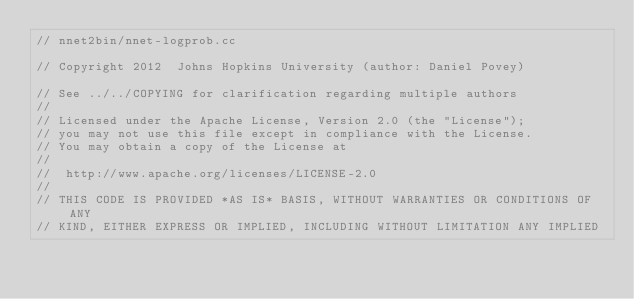Convert code to text. <code><loc_0><loc_0><loc_500><loc_500><_C++_>// nnet2bin/nnet-logprob.cc

// Copyright 2012  Johns Hopkins University (author: Daniel Povey)

// See ../../COPYING for clarification regarding multiple authors
//
// Licensed under the Apache License, Version 2.0 (the "License");
// you may not use this file except in compliance with the License.
// You may obtain a copy of the License at
//
//  http://www.apache.org/licenses/LICENSE-2.0
//
// THIS CODE IS PROVIDED *AS IS* BASIS, WITHOUT WARRANTIES OR CONDITIONS OF ANY
// KIND, EITHER EXPRESS OR IMPLIED, INCLUDING WITHOUT LIMITATION ANY IMPLIED</code> 